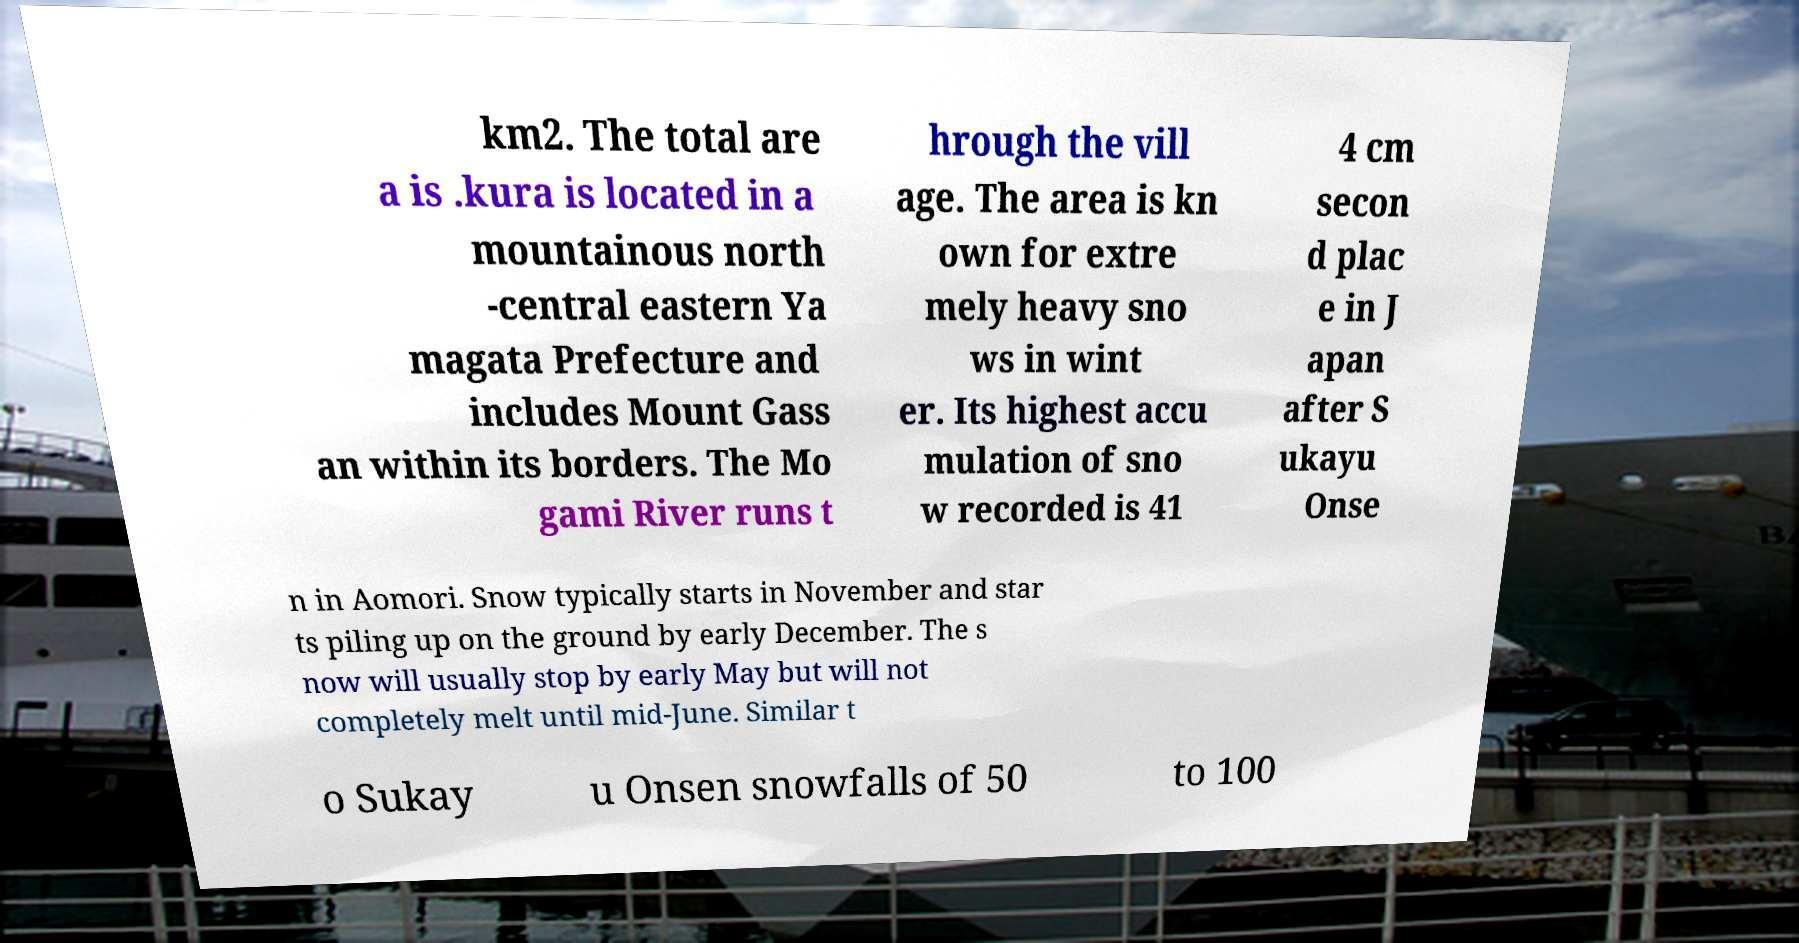Could you extract and type out the text from this image? km2. The total are a is .kura is located in a mountainous north -central eastern Ya magata Prefecture and includes Mount Gass an within its borders. The Mo gami River runs t hrough the vill age. The area is kn own for extre mely heavy sno ws in wint er. Its highest accu mulation of sno w recorded is 41 4 cm secon d plac e in J apan after S ukayu Onse n in Aomori. Snow typically starts in November and star ts piling up on the ground by early December. The s now will usually stop by early May but will not completely melt until mid-June. Similar t o Sukay u Onsen snowfalls of 50 to 100 